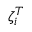<formula> <loc_0><loc_0><loc_500><loc_500>\zeta _ { i } ^ { T }</formula> 